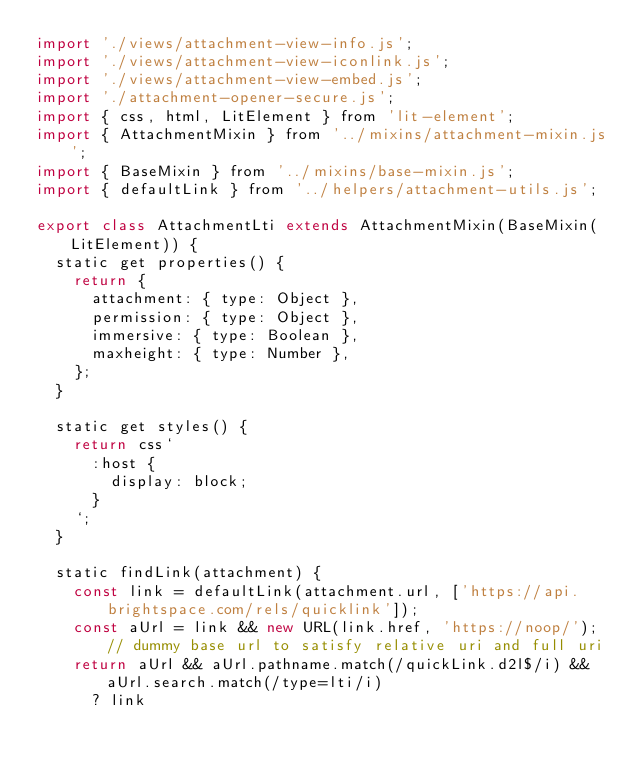Convert code to text. <code><loc_0><loc_0><loc_500><loc_500><_JavaScript_>import './views/attachment-view-info.js';
import './views/attachment-view-iconlink.js';
import './views/attachment-view-embed.js';
import './attachment-opener-secure.js';
import { css, html, LitElement } from 'lit-element';
import { AttachmentMixin } from '../mixins/attachment-mixin.js';
import { BaseMixin } from '../mixins/base-mixin.js';
import { defaultLink } from '../helpers/attachment-utils.js';

export class AttachmentLti extends AttachmentMixin(BaseMixin(LitElement)) {
	static get properties() {
		return {
			attachment: { type: Object },
			permission: { type: Object },
			immersive: { type: Boolean },
			maxheight: { type: Number },
		};
	}

	static get styles() {
		return css`
			:host {
				display: block;
			}
		`;
	}

	static findLink(attachment) {
		const link = defaultLink(attachment.url, ['https://api.brightspace.com/rels/quicklink']);
		const aUrl = link && new URL(link.href, 'https://noop/'); // dummy base url to satisfy relative uri and full uri
		return aUrl && aUrl.pathname.match(/quickLink.d2l$/i) && aUrl.search.match(/type=lti/i)
			? link</code> 